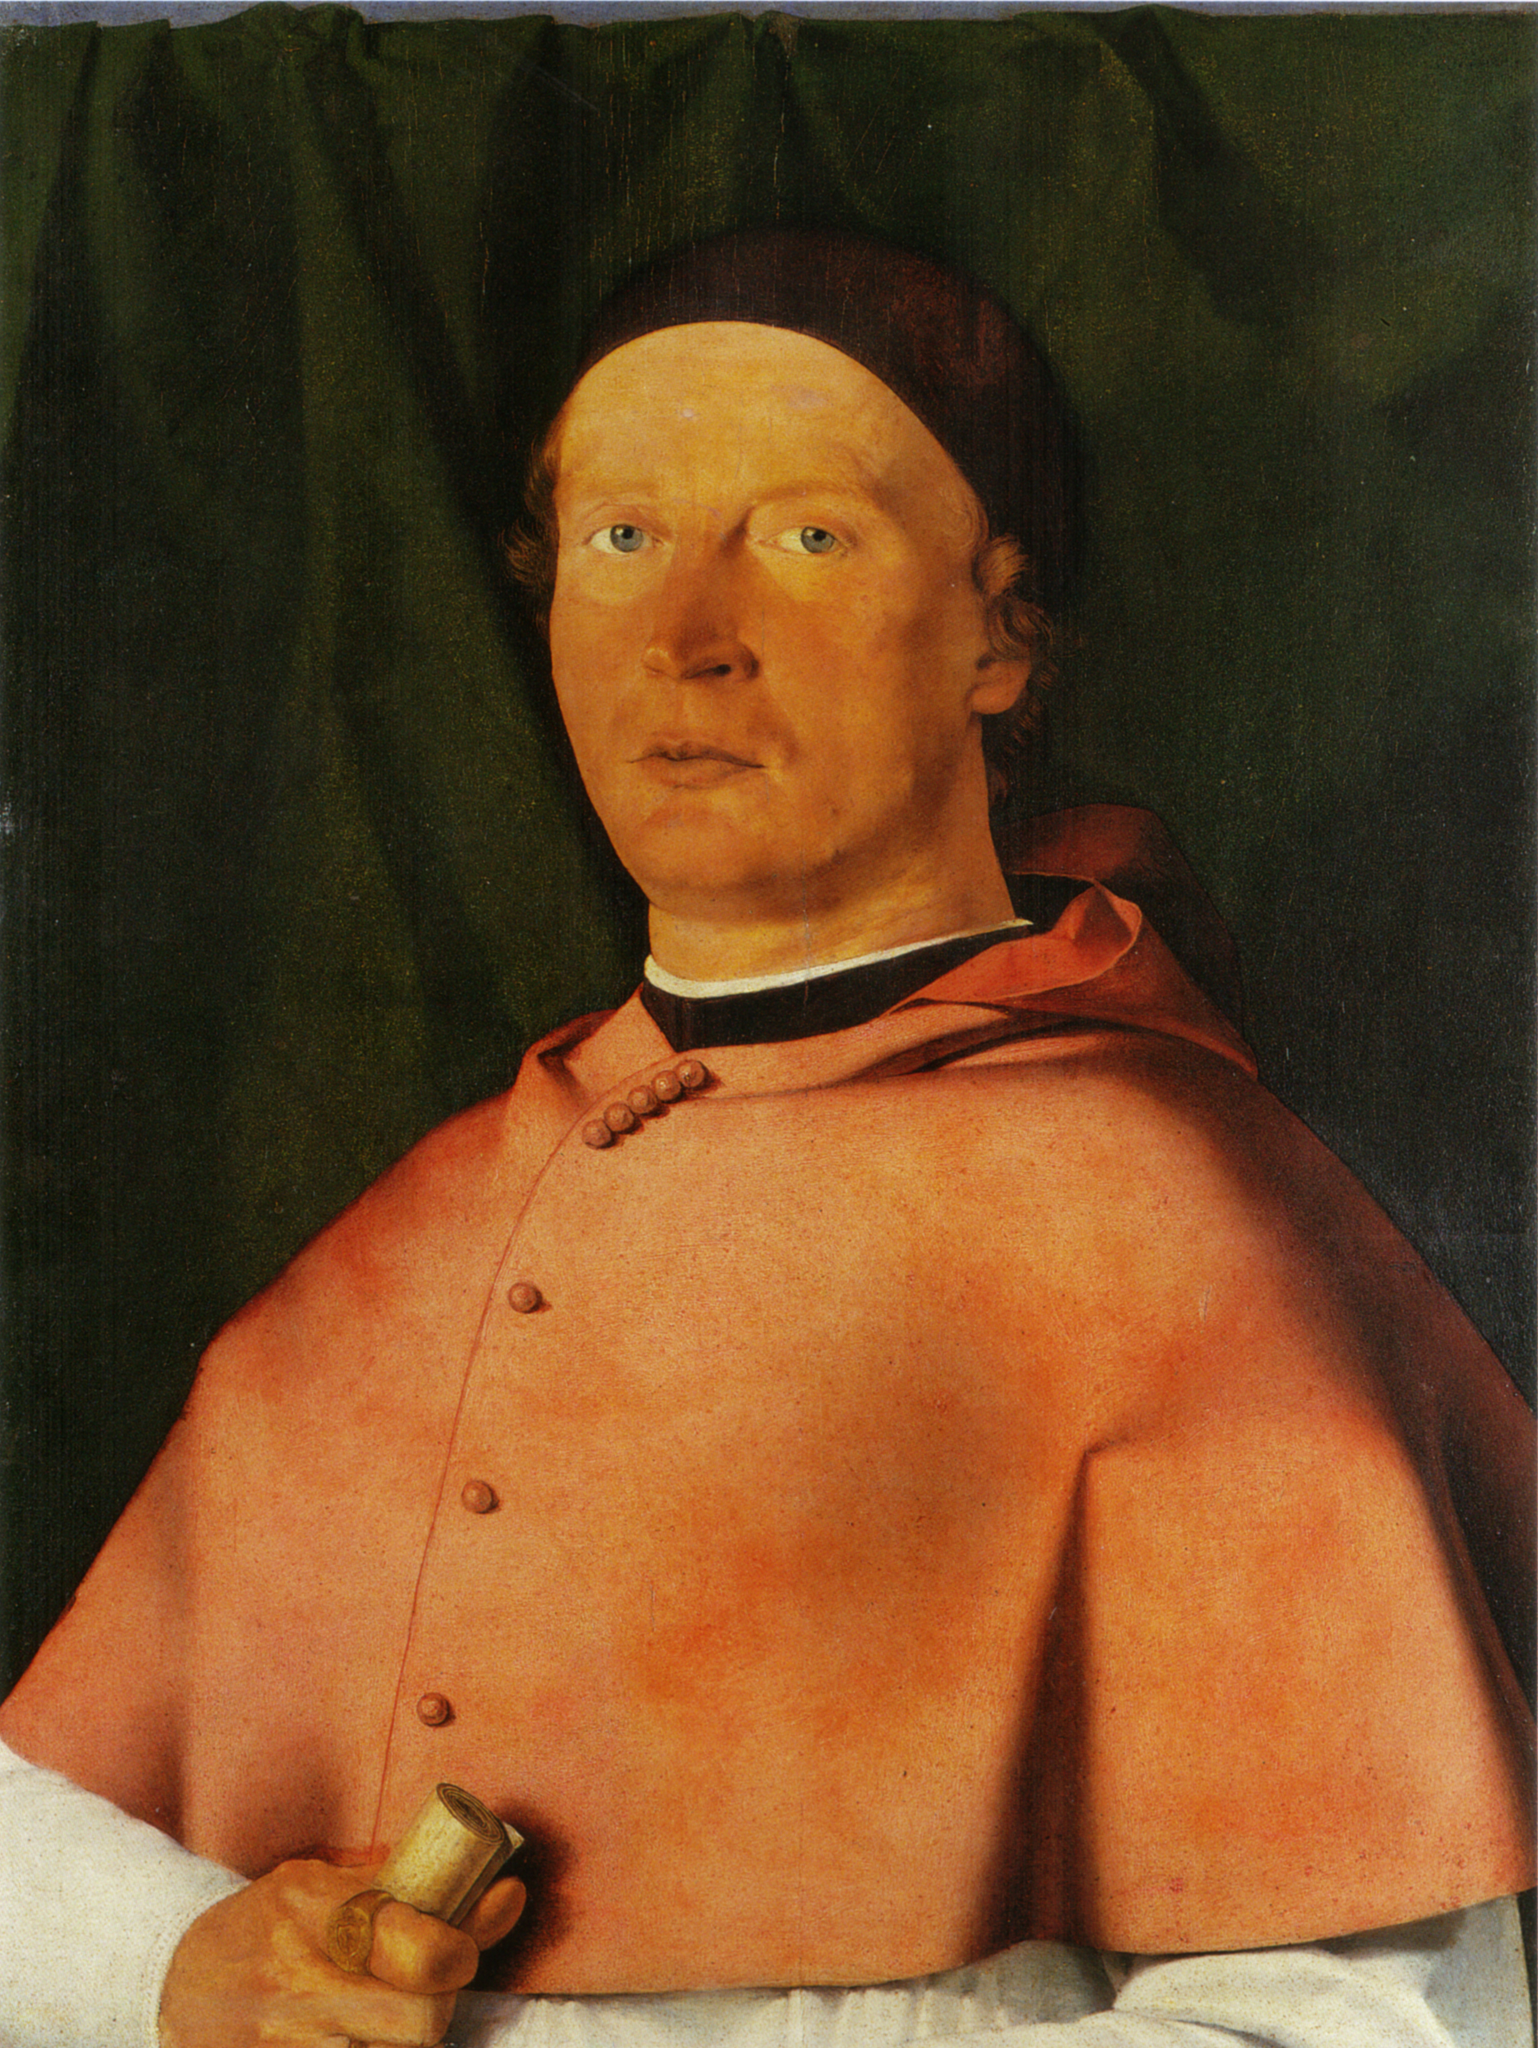What do you think is going on in this snapshot? This painting captures an individual, likely a man of status or importance, based on his attire and the objects he holds. He wears a vibrant red robe and a black cap, standard for figures of authority or wealth during certain historical periods. In his right hand, he holds a small gold object, possibly an artifact or a tool signifying power or personal significance. The dark green curtain in the background offers a striking contrast that highlights the subject, accentuating his importance and focusing the viewer's attention on him. This work is likely done in oil on panel which gives the colors a rich depth and emphasizes the texture of his attire and the curtain. Through his direct gaze, the artist conveys confidence and influence, inviting the viewer to contemplate the historical and social context surrounding the portrait. 